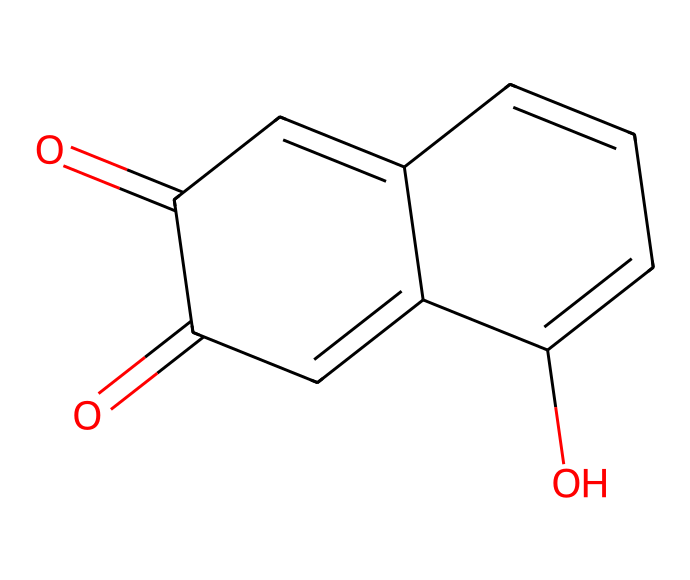What is the total number of carbon atoms in the structure? By analyzing the SMILES representation, we count all the carbon (C) atoms present. In this case, there are 10 carbon atoms visible in the cyclic structure.
Answer: 10 How many oxygen atoms are present in this compound? Looking through the chemical representation, we see two oxygen (O) atoms included within the central part of the structure.
Answer: 2 What type of compounds does this dye belong to? The chemical structure indicates that it has unsaturated rings and conjugated systems, characteristic of natural dyes. Hence, it qualifies as a phenolic compound, which is common in natural dyes like henna.
Answer: phenolic What functional groups can be identified in this chemical structure? Upon reviewing the structure, we can identify ketone groups (C=O) due to the carbonyl functional group seen in the compound, alongside a hydroxyl group (–OH) on one of the carbon atoms.
Answer: ketone and hydroxyl Which structural element in henna contributes to its dyeing properties? The presence of the conjugated double bonds systems (C=C) through the unsaturation and cyclic nature aids in strong light absorption, giving it dyeing properties. Therefore, the conjugated double bond system is crucial.
Answer: conjugated double bond system 